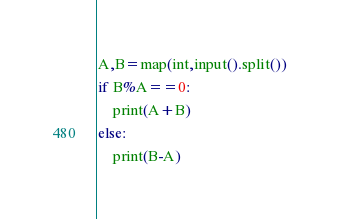<code> <loc_0><loc_0><loc_500><loc_500><_Python_>A,B=map(int,input().split())
if B%A==0:
    print(A+B)
else:
    print(B-A)
</code> 